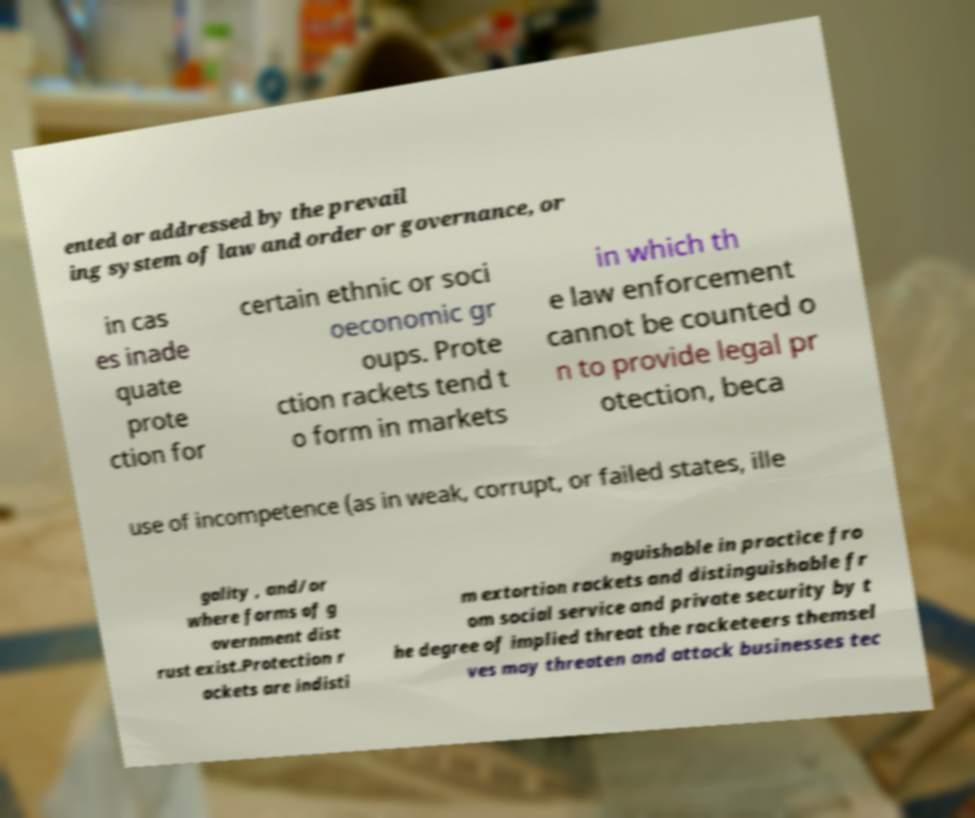Could you extract and type out the text from this image? ented or addressed by the prevail ing system of law and order or governance, or in cas es inade quate prote ction for certain ethnic or soci oeconomic gr oups. Prote ction rackets tend t o form in markets in which th e law enforcement cannot be counted o n to provide legal pr otection, beca use of incompetence (as in weak, corrupt, or failed states, ille gality , and/or where forms of g overnment dist rust exist.Protection r ackets are indisti nguishable in practice fro m extortion rackets and distinguishable fr om social service and private security by t he degree of implied threat the racketeers themsel ves may threaten and attack businesses tec 